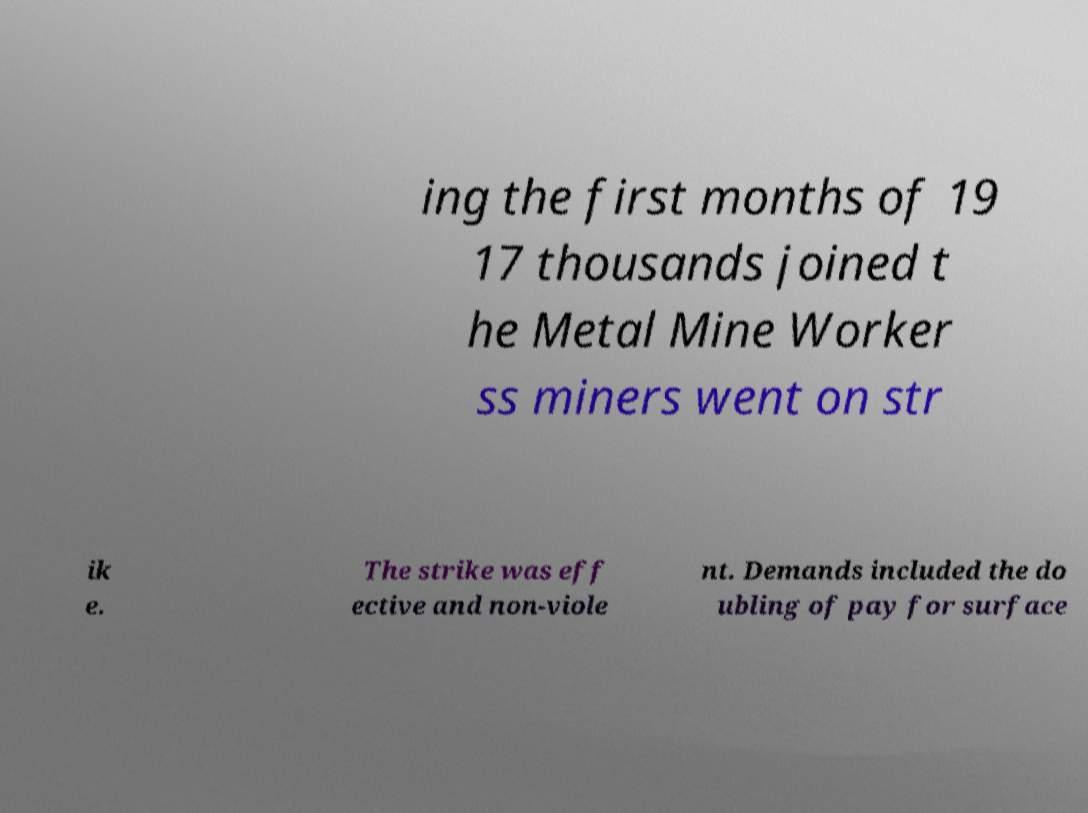Can you read and provide the text displayed in the image?This photo seems to have some interesting text. Can you extract and type it out for me? ing the first months of 19 17 thousands joined t he Metal Mine Worker ss miners went on str ik e. The strike was eff ective and non-viole nt. Demands included the do ubling of pay for surface 